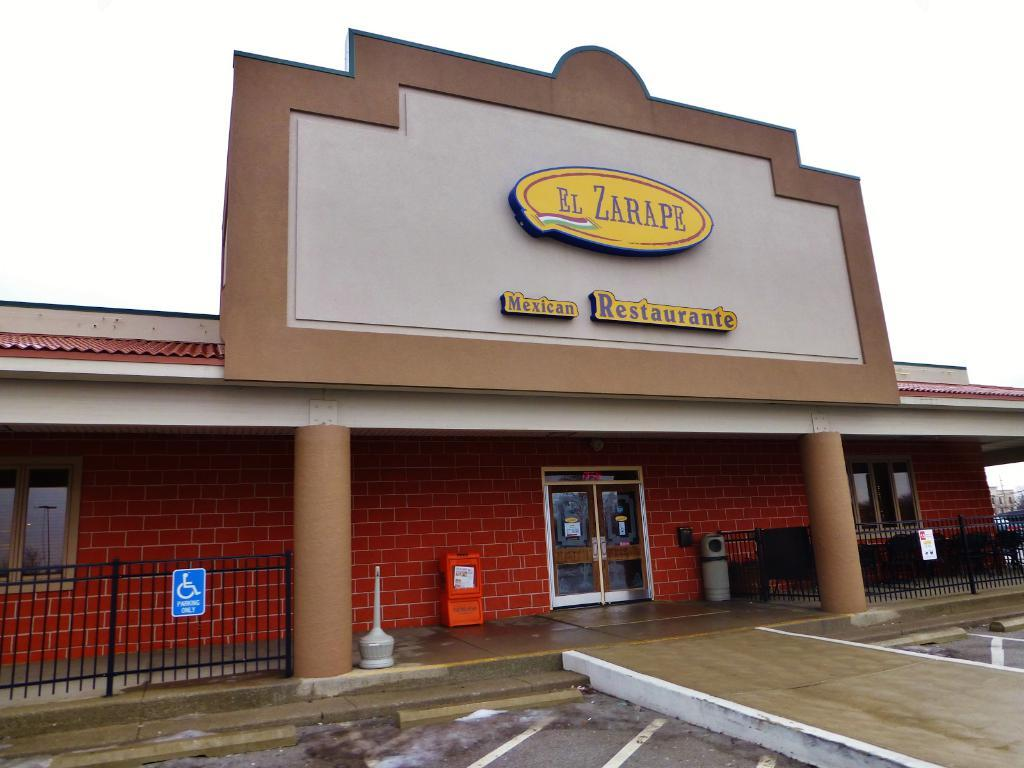What type of establishment is depicted in the image? There is a store in the image. How can the store be identified? The store has a name on top. What feature is present in front of the store? There is a railing in front of the store. What can be seen in the bottom right corner of the image? There is a path in the bottom right corner of the image. What is visible in the background of the image? The sky is visible in the background of the image. How many planes are parked in front of the store in the image? There are no planes present in the image; it features a store with a railing in front. What type of bean is growing on the side of the store in the image? There is no bean plant growing on the side of the store in the image. 